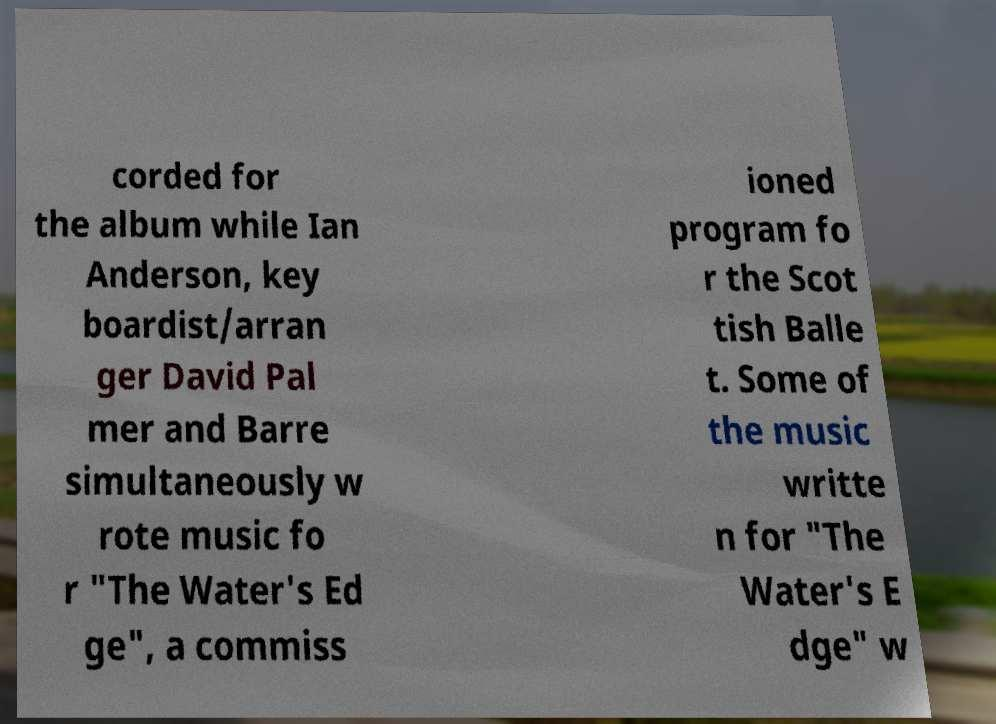Could you assist in decoding the text presented in this image and type it out clearly? corded for the album while Ian Anderson, key boardist/arran ger David Pal mer and Barre simultaneously w rote music fo r "The Water's Ed ge", a commiss ioned program fo r the Scot tish Balle t. Some of the music writte n for "The Water's E dge" w 